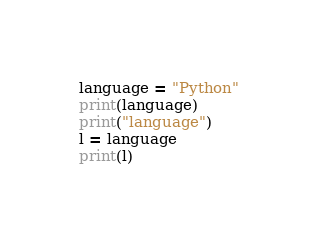<code> <loc_0><loc_0><loc_500><loc_500><_Python_>language = "Python"
print(language)
print("language")
l = language
print(l)
</code> 